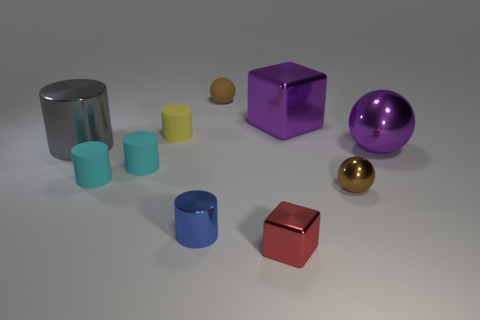Subtract all yellow cylinders. How many cylinders are left? 4 Subtract all blue cylinders. How many cylinders are left? 4 Subtract all blue cylinders. Subtract all cyan blocks. How many cylinders are left? 4 Subtract all cubes. How many objects are left? 8 Add 4 small gray shiny things. How many small gray shiny things exist? 4 Subtract 0 brown cylinders. How many objects are left? 10 Subtract all big red rubber cubes. Subtract all shiny objects. How many objects are left? 4 Add 6 large spheres. How many large spheres are left? 7 